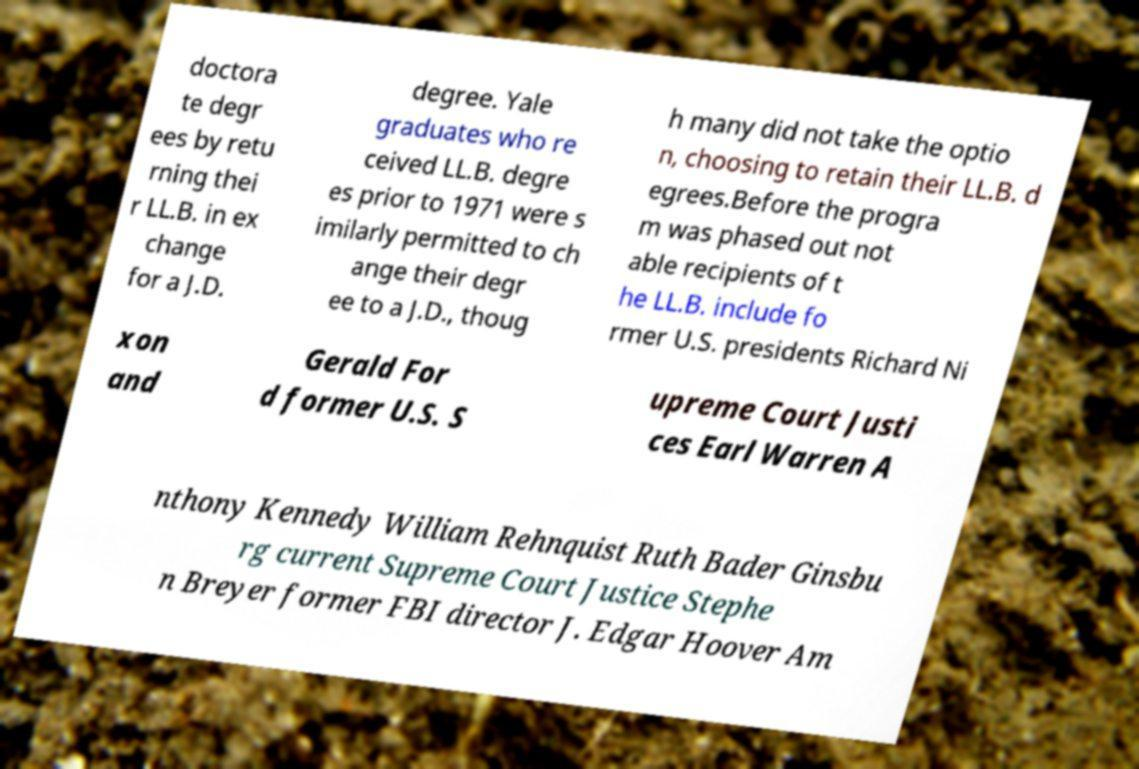Could you extract and type out the text from this image? doctora te degr ees by retu rning thei r LL.B. in ex change for a J.D. degree. Yale graduates who re ceived LL.B. degre es prior to 1971 were s imilarly permitted to ch ange their degr ee to a J.D., thoug h many did not take the optio n, choosing to retain their LL.B. d egrees.Before the progra m was phased out not able recipients of t he LL.B. include fo rmer U.S. presidents Richard Ni xon and Gerald For d former U.S. S upreme Court Justi ces Earl Warren A nthony Kennedy William Rehnquist Ruth Bader Ginsbu rg current Supreme Court Justice Stephe n Breyer former FBI director J. Edgar Hoover Am 